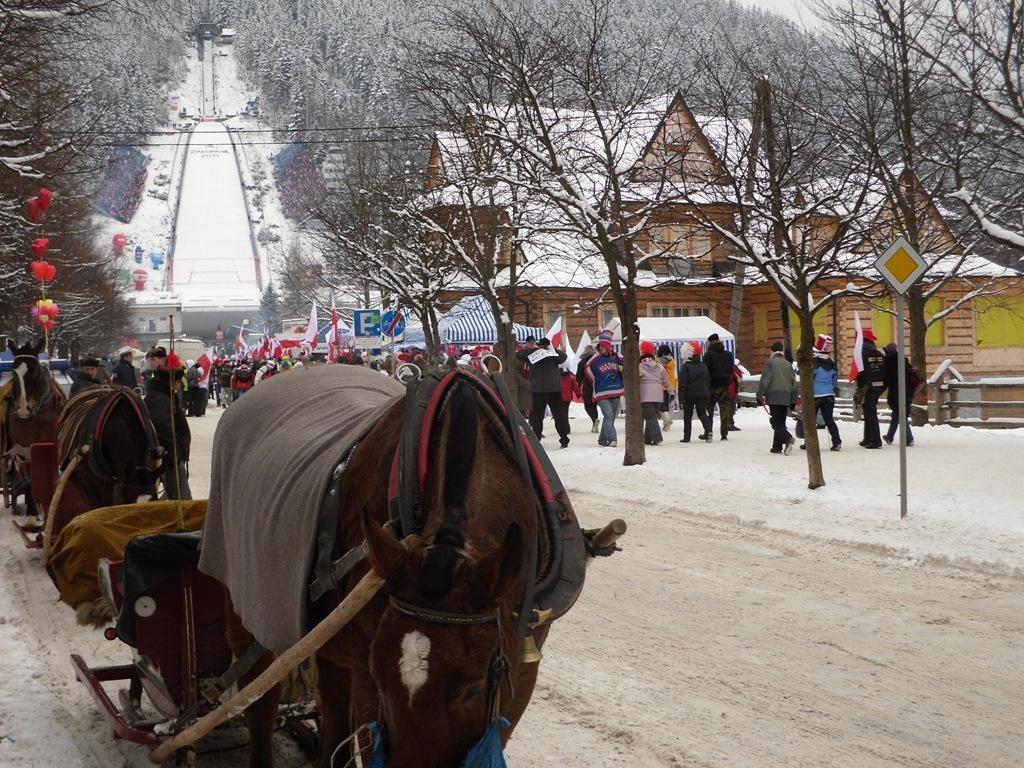What animals can be seen in the image? There are horses in the image. Who else is present in the image besides the horses? A: There are people in the image. What type of temporary shelters are visible in the image? There are tents in the image. What is being used to support the tents? There are lags in the image. What type of vegetation is present in the image? There are trees in the image. What type of signage is visible in the image? There are signboards in the image. What type of permanent structures are visible in the image? There are houses in the image. What is the state of the water in the image? There is ice in the image. What type of pathway is visible in the image? There is a way in the image. What part of the natural environment is visible in the image? The sky is visible in the image. What type of mask is being worn by the horses in the image? There are no masks present in the image; the horses are not wearing any. What is the opinion of the tooth in the image? There is no tooth present in the image, so it cannot have an opinion. 